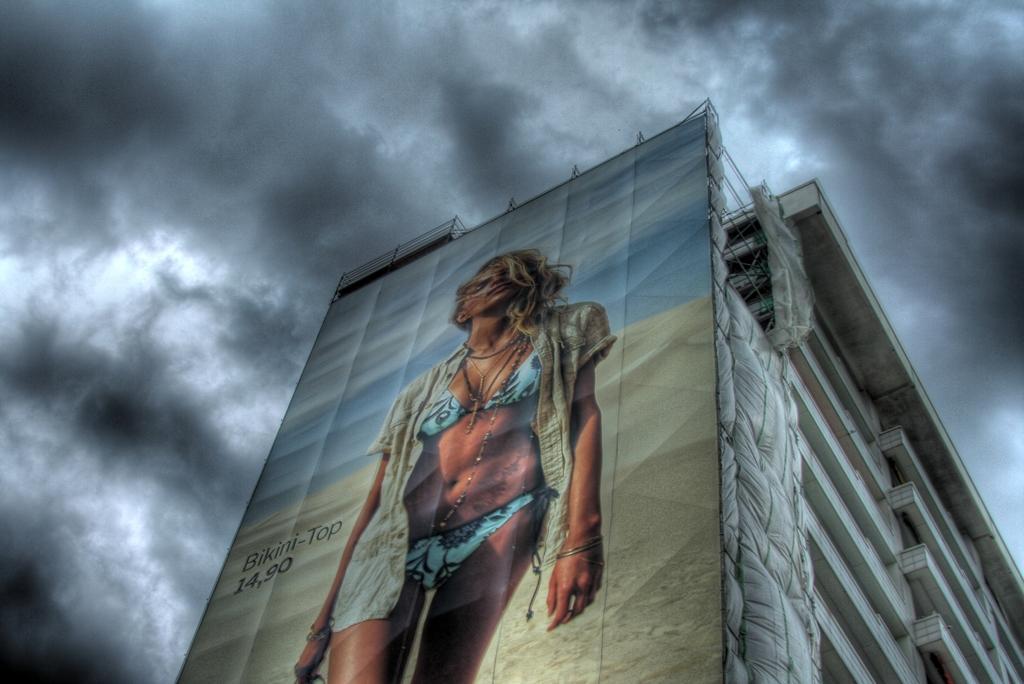Describe this image in one or two sentences. In this image, we can see a board on the building and on the board, we can see some text and there is a picture of a lady. In the background, there are clouds in the sky. 